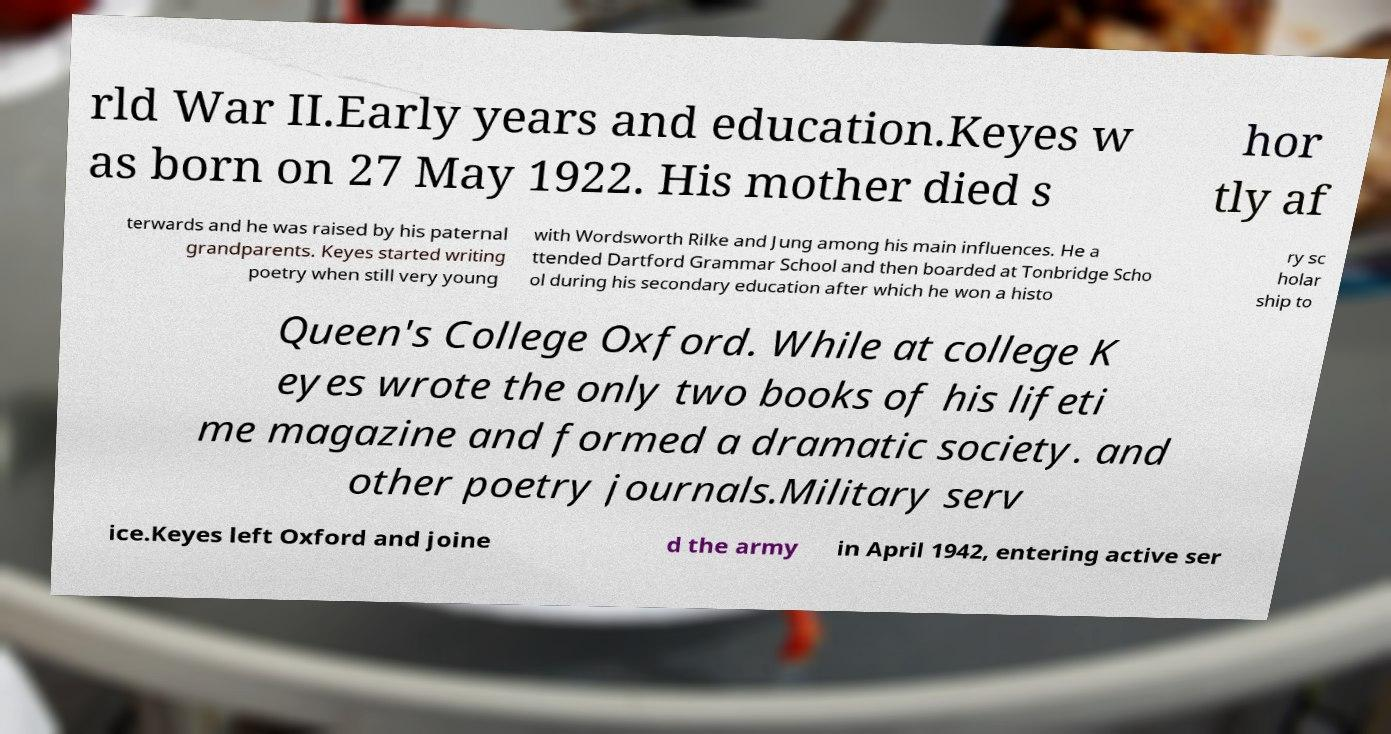I need the written content from this picture converted into text. Can you do that? rld War II.Early years and education.Keyes w as born on 27 May 1922. His mother died s hor tly af terwards and he was raised by his paternal grandparents. Keyes started writing poetry when still very young with Wordsworth Rilke and Jung among his main influences. He a ttended Dartford Grammar School and then boarded at Tonbridge Scho ol during his secondary education after which he won a histo ry sc holar ship to Queen's College Oxford. While at college K eyes wrote the only two books of his lifeti me magazine and formed a dramatic society. and other poetry journals.Military serv ice.Keyes left Oxford and joine d the army in April 1942, entering active ser 